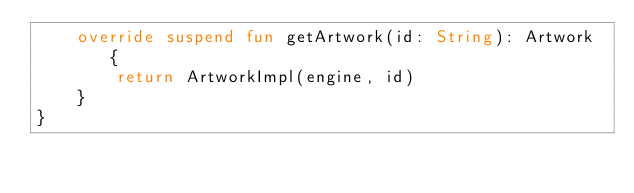<code> <loc_0><loc_0><loc_500><loc_500><_Kotlin_>    override suspend fun getArtwork(id: String): Artwork {
        return ArtworkImpl(engine, id)
    }
}</code> 